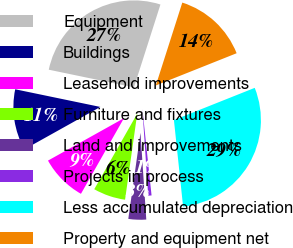Convert chart. <chart><loc_0><loc_0><loc_500><loc_500><pie_chart><fcel>Equipment<fcel>Buildings<fcel>Leasehold improvements<fcel>Furniture and fixtures<fcel>Land and improvements<fcel>Projects in process<fcel>Less accumulated depreciation<fcel>Property and equipment net<nl><fcel>26.67%<fcel>11.36%<fcel>8.67%<fcel>5.99%<fcel>3.3%<fcel>0.62%<fcel>29.36%<fcel>14.04%<nl></chart> 